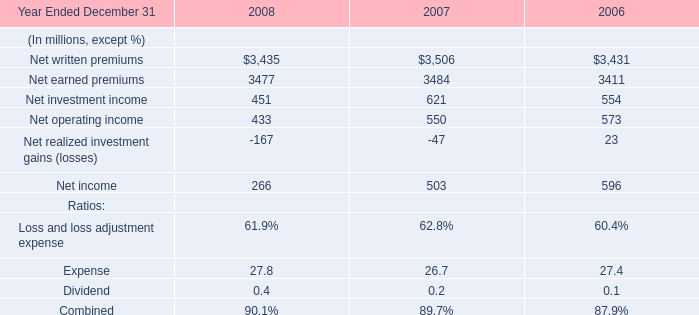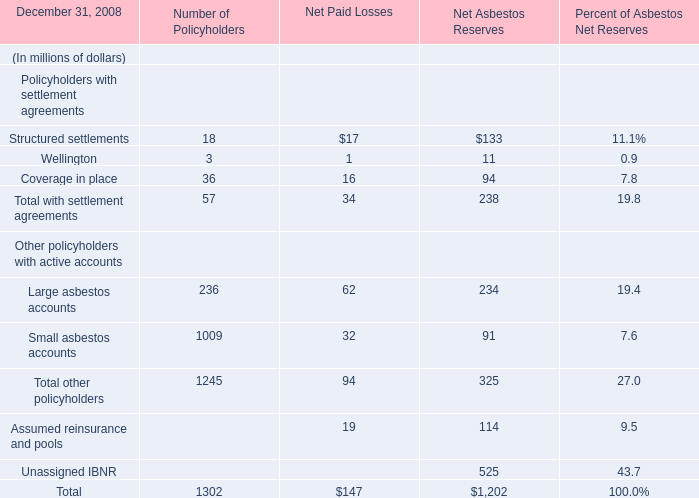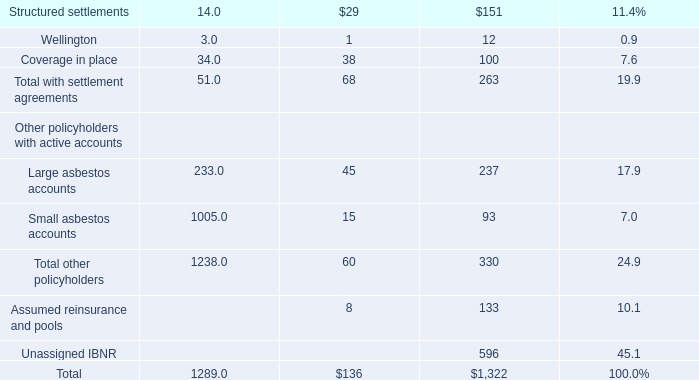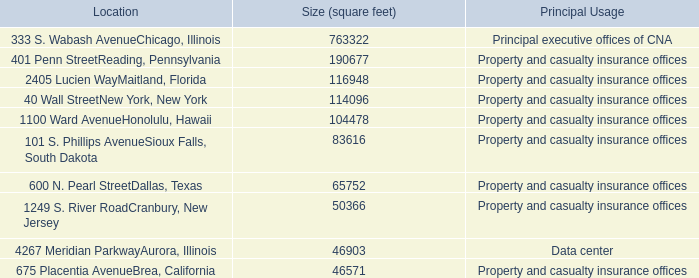What is the sum of elements for Net Asbestos Reserves in the range of 200 and 1000 in 2008? (in million) 
Computations: (234 + 525)
Answer: 759.0. 